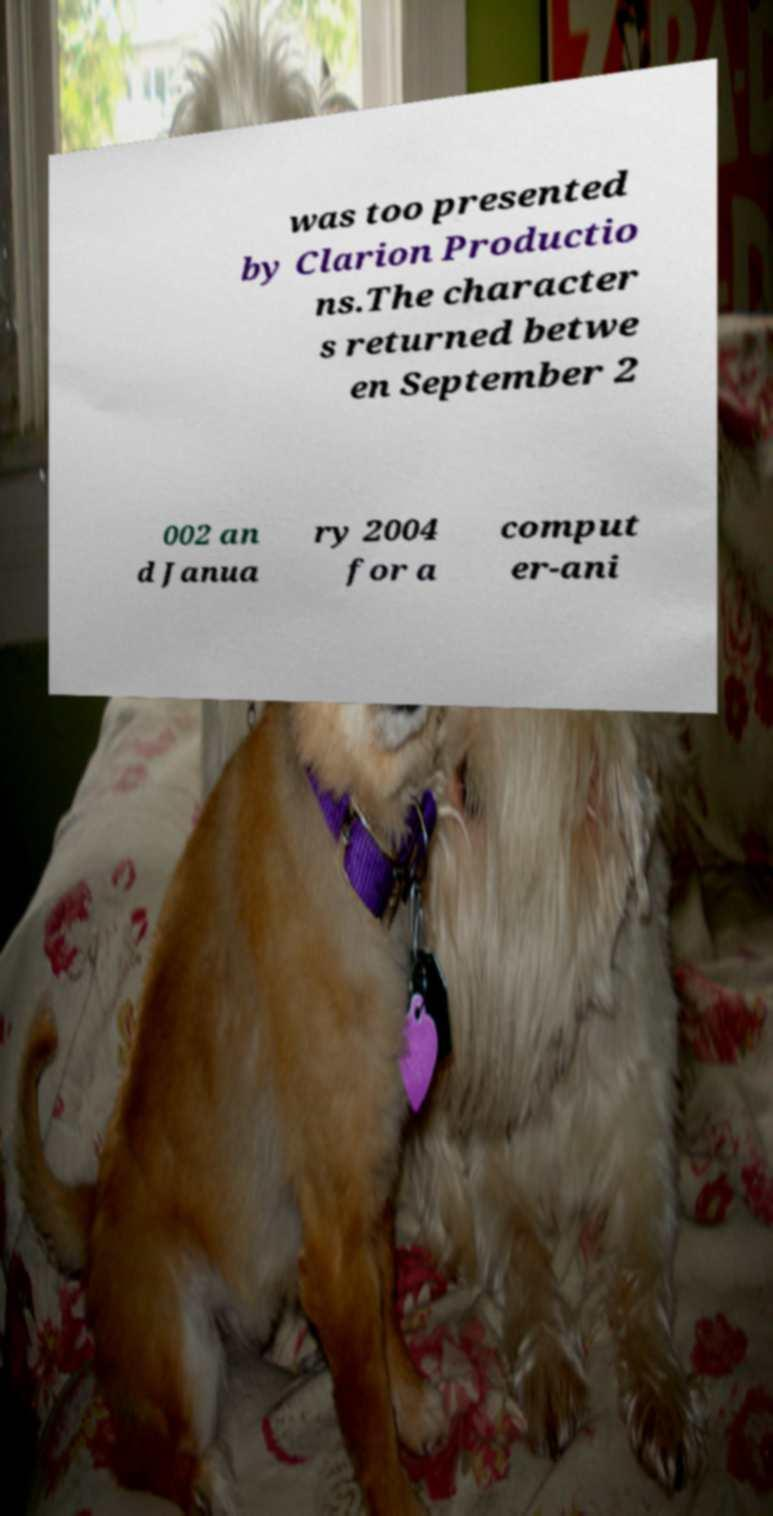Can you read and provide the text displayed in the image?This photo seems to have some interesting text. Can you extract and type it out for me? was too presented by Clarion Productio ns.The character s returned betwe en September 2 002 an d Janua ry 2004 for a comput er-ani 